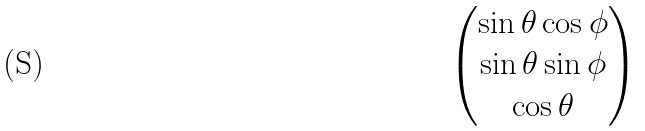<formula> <loc_0><loc_0><loc_500><loc_500>\begin{pmatrix} \sin { \theta } \cos { \phi } \\ \sin { \theta } \sin { \phi } \\ \cos { \theta } \end{pmatrix}</formula> 